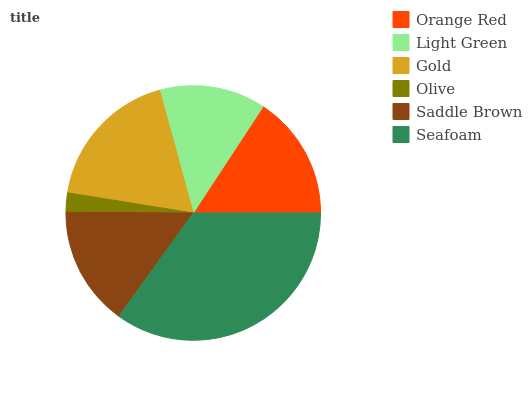Is Olive the minimum?
Answer yes or no. Yes. Is Seafoam the maximum?
Answer yes or no. Yes. Is Light Green the minimum?
Answer yes or no. No. Is Light Green the maximum?
Answer yes or no. No. Is Orange Red greater than Light Green?
Answer yes or no. Yes. Is Light Green less than Orange Red?
Answer yes or no. Yes. Is Light Green greater than Orange Red?
Answer yes or no. No. Is Orange Red less than Light Green?
Answer yes or no. No. Is Orange Red the high median?
Answer yes or no. Yes. Is Saddle Brown the low median?
Answer yes or no. Yes. Is Olive the high median?
Answer yes or no. No. Is Gold the low median?
Answer yes or no. No. 